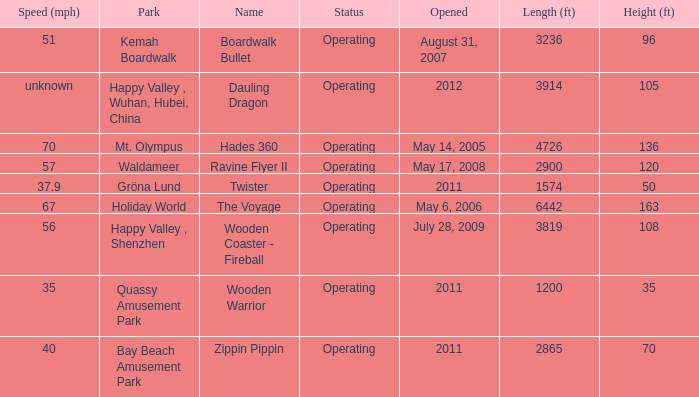How many parks are called mt. olympus 1.0. 